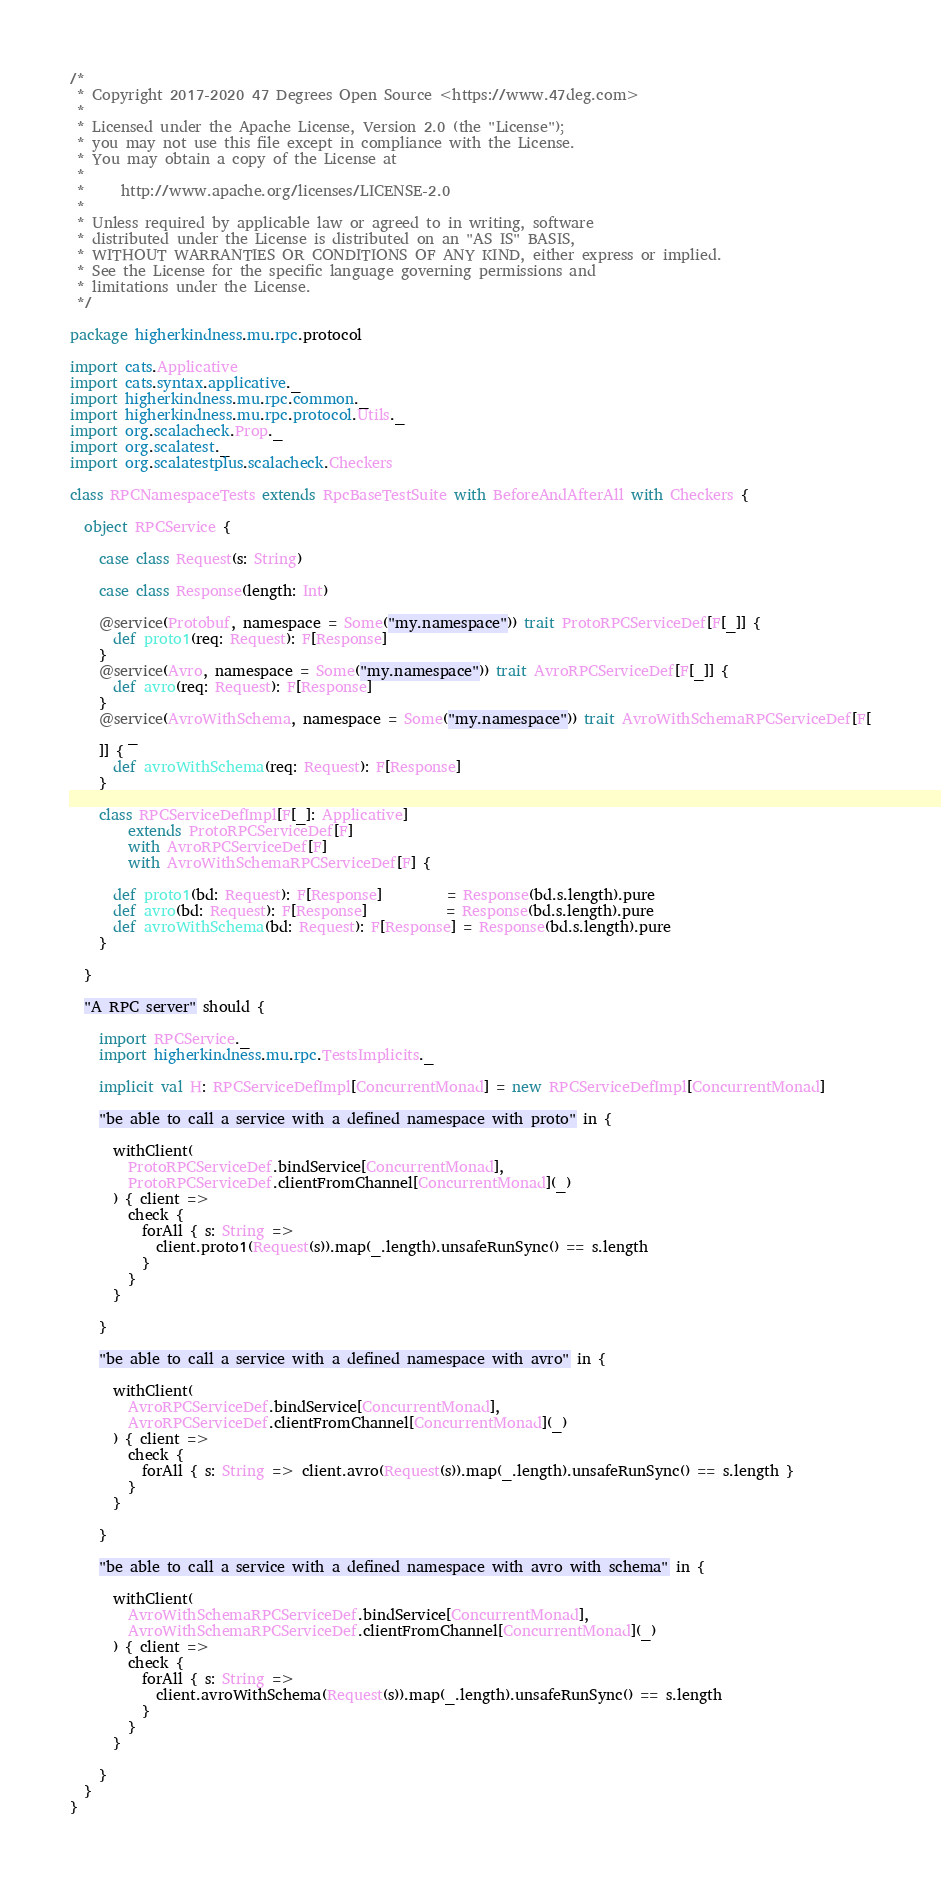<code> <loc_0><loc_0><loc_500><loc_500><_Scala_>/*
 * Copyright 2017-2020 47 Degrees Open Source <https://www.47deg.com>
 *
 * Licensed under the Apache License, Version 2.0 (the "License");
 * you may not use this file except in compliance with the License.
 * You may obtain a copy of the License at
 *
 *     http://www.apache.org/licenses/LICENSE-2.0
 *
 * Unless required by applicable law or agreed to in writing, software
 * distributed under the License is distributed on an "AS IS" BASIS,
 * WITHOUT WARRANTIES OR CONDITIONS OF ANY KIND, either express or implied.
 * See the License for the specific language governing permissions and
 * limitations under the License.
 */

package higherkindness.mu.rpc.protocol

import cats.Applicative
import cats.syntax.applicative._
import higherkindness.mu.rpc.common._
import higherkindness.mu.rpc.protocol.Utils._
import org.scalacheck.Prop._
import org.scalatest._
import org.scalatestplus.scalacheck.Checkers

class RPCNamespaceTests extends RpcBaseTestSuite with BeforeAndAfterAll with Checkers {

  object RPCService {

    case class Request(s: String)

    case class Response(length: Int)

    @service(Protobuf, namespace = Some("my.namespace")) trait ProtoRPCServiceDef[F[_]] {
      def proto1(req: Request): F[Response]
    }
    @service(Avro, namespace = Some("my.namespace")) trait AvroRPCServiceDef[F[_]] {
      def avro(req: Request): F[Response]
    }
    @service(AvroWithSchema, namespace = Some("my.namespace")) trait AvroWithSchemaRPCServiceDef[F[
        _
    ]] {
      def avroWithSchema(req: Request): F[Response]
    }

    class RPCServiceDefImpl[F[_]: Applicative]
        extends ProtoRPCServiceDef[F]
        with AvroRPCServiceDef[F]
        with AvroWithSchemaRPCServiceDef[F] {

      def proto1(bd: Request): F[Response]         = Response(bd.s.length).pure
      def avro(bd: Request): F[Response]           = Response(bd.s.length).pure
      def avroWithSchema(bd: Request): F[Response] = Response(bd.s.length).pure
    }

  }

  "A RPC server" should {

    import RPCService._
    import higherkindness.mu.rpc.TestsImplicits._

    implicit val H: RPCServiceDefImpl[ConcurrentMonad] = new RPCServiceDefImpl[ConcurrentMonad]

    "be able to call a service with a defined namespace with proto" in {

      withClient(
        ProtoRPCServiceDef.bindService[ConcurrentMonad],
        ProtoRPCServiceDef.clientFromChannel[ConcurrentMonad](_)
      ) { client =>
        check {
          forAll { s: String =>
            client.proto1(Request(s)).map(_.length).unsafeRunSync() == s.length
          }
        }
      }

    }

    "be able to call a service with a defined namespace with avro" in {

      withClient(
        AvroRPCServiceDef.bindService[ConcurrentMonad],
        AvroRPCServiceDef.clientFromChannel[ConcurrentMonad](_)
      ) { client =>
        check {
          forAll { s: String => client.avro(Request(s)).map(_.length).unsafeRunSync() == s.length }
        }
      }

    }

    "be able to call a service with a defined namespace with avro with schema" in {

      withClient(
        AvroWithSchemaRPCServiceDef.bindService[ConcurrentMonad],
        AvroWithSchemaRPCServiceDef.clientFromChannel[ConcurrentMonad](_)
      ) { client =>
        check {
          forAll { s: String =>
            client.avroWithSchema(Request(s)).map(_.length).unsafeRunSync() == s.length
          }
        }
      }

    }
  }
}
</code> 